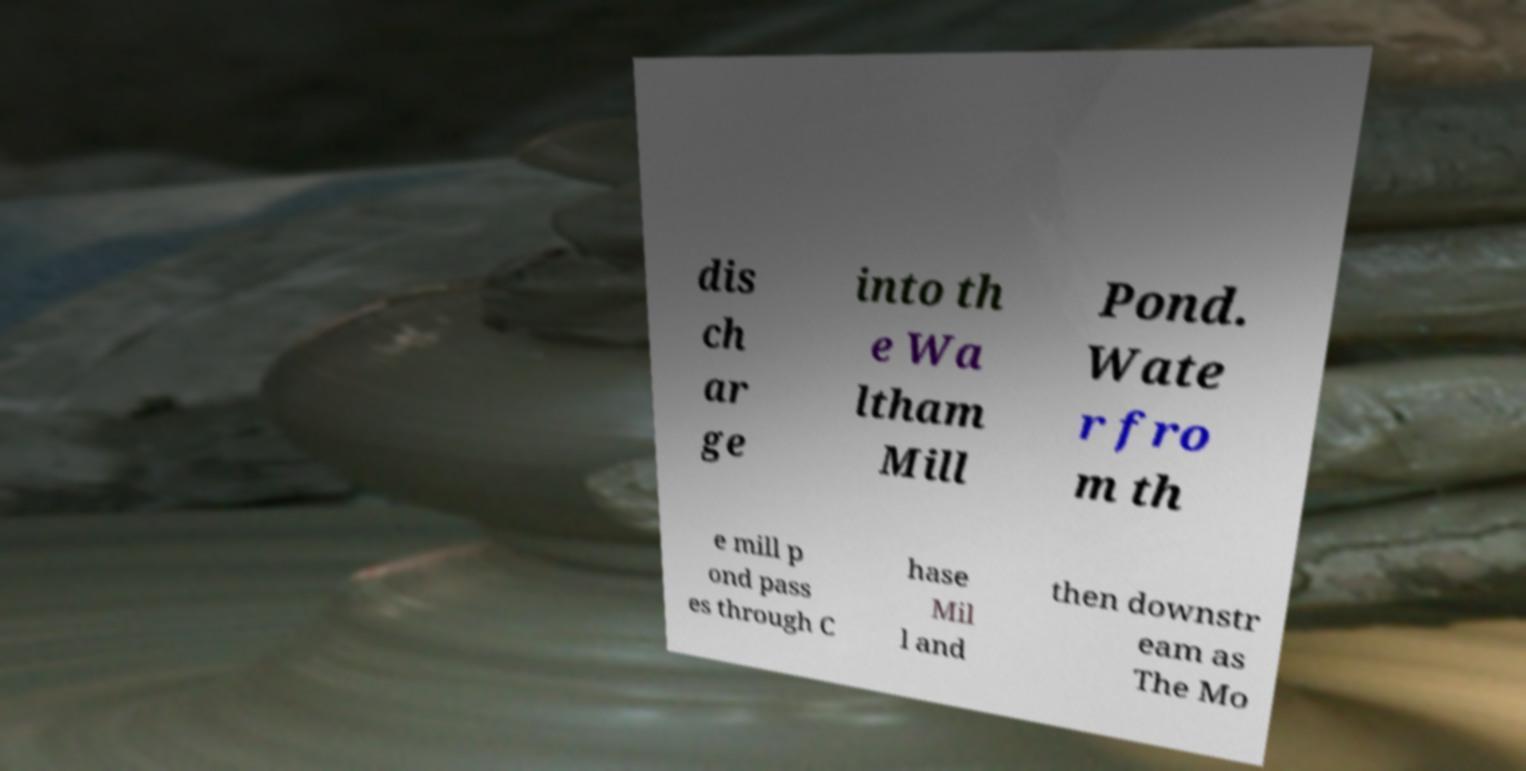Could you extract and type out the text from this image? dis ch ar ge into th e Wa ltham Mill Pond. Wate r fro m th e mill p ond pass es through C hase Mil l and then downstr eam as The Mo 